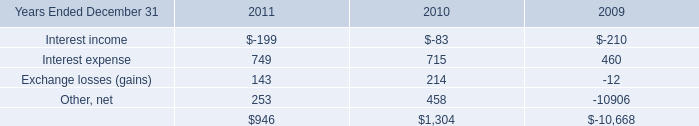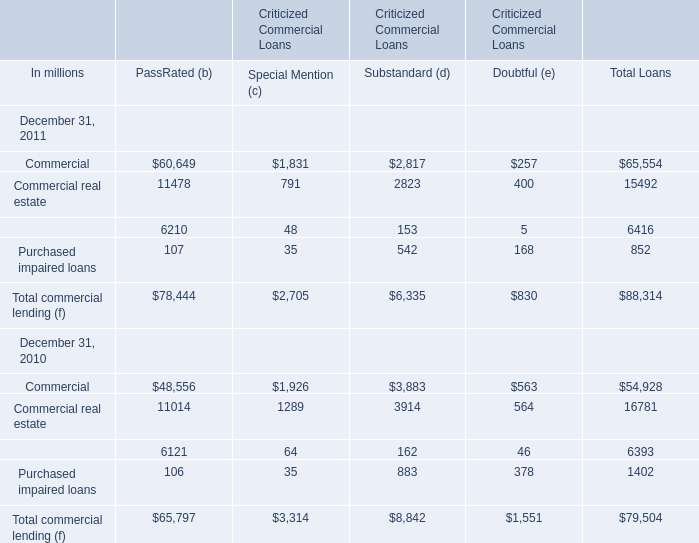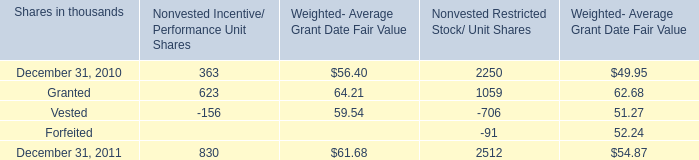How many PassRated (b) exceed the average of PassRated (b) in 2011? 
Answer: 1. 